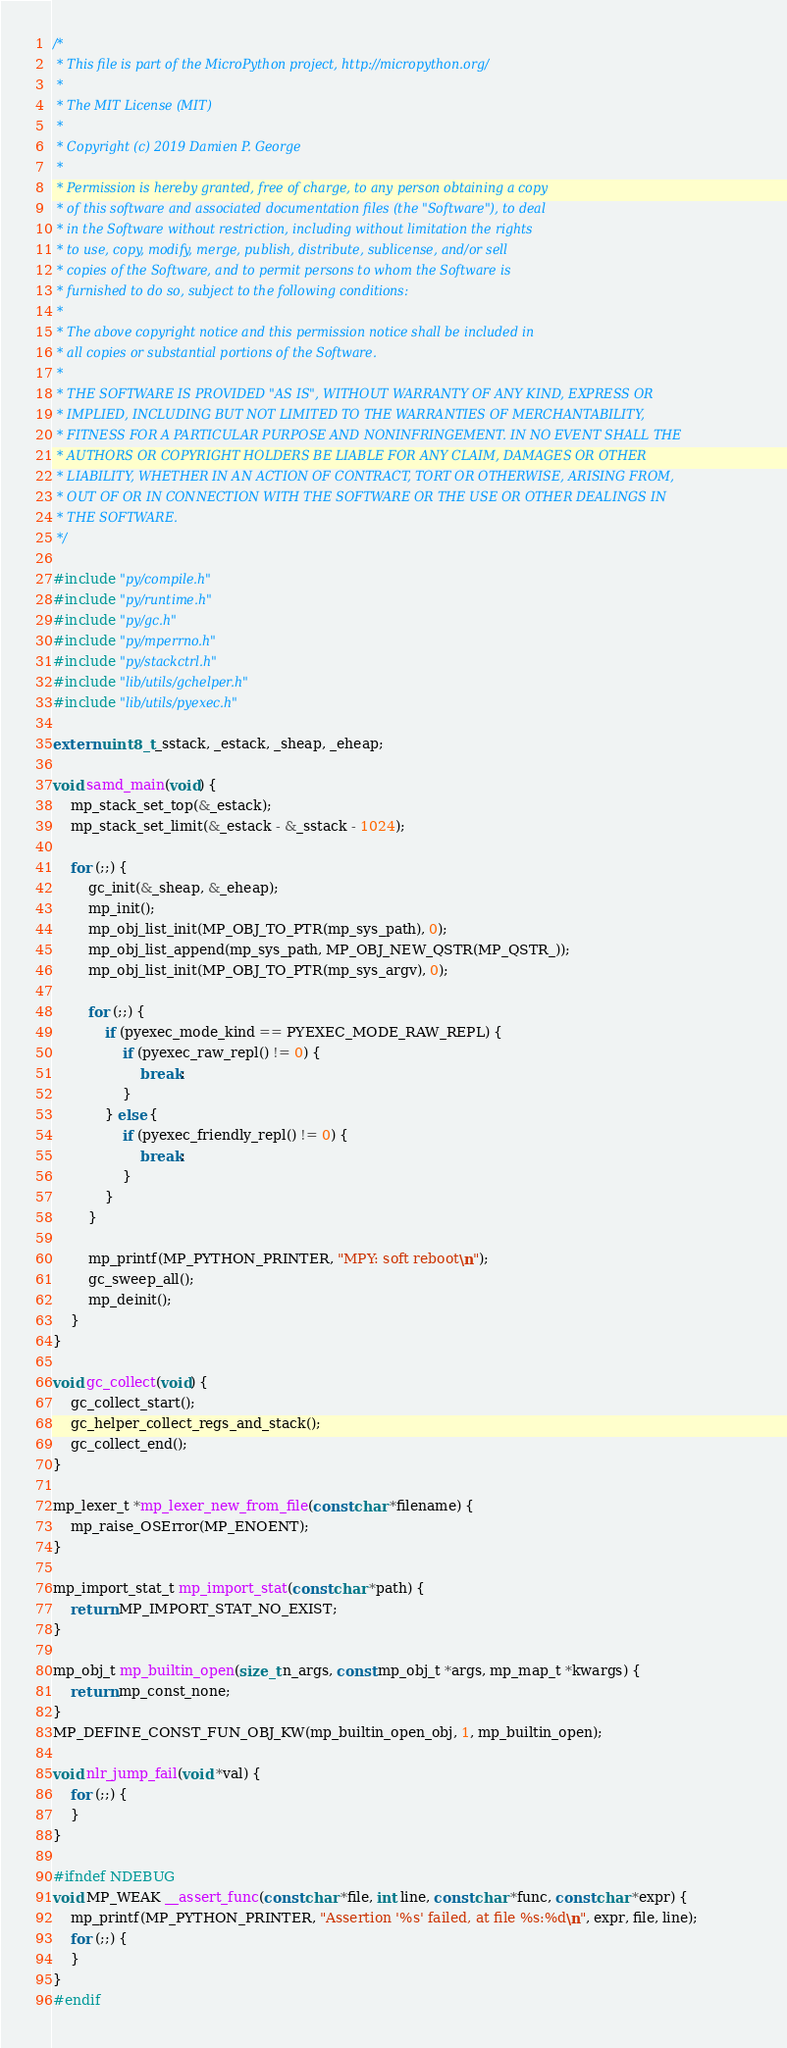<code> <loc_0><loc_0><loc_500><loc_500><_C_>/*
 * This file is part of the MicroPython project, http://micropython.org/
 *
 * The MIT License (MIT)
 *
 * Copyright (c) 2019 Damien P. George
 *
 * Permission is hereby granted, free of charge, to any person obtaining a copy
 * of this software and associated documentation files (the "Software"), to deal
 * in the Software without restriction, including without limitation the rights
 * to use, copy, modify, merge, publish, distribute, sublicense, and/or sell
 * copies of the Software, and to permit persons to whom the Software is
 * furnished to do so, subject to the following conditions:
 *
 * The above copyright notice and this permission notice shall be included in
 * all copies or substantial portions of the Software.
 *
 * THE SOFTWARE IS PROVIDED "AS IS", WITHOUT WARRANTY OF ANY KIND, EXPRESS OR
 * IMPLIED, INCLUDING BUT NOT LIMITED TO THE WARRANTIES OF MERCHANTABILITY,
 * FITNESS FOR A PARTICULAR PURPOSE AND NONINFRINGEMENT. IN NO EVENT SHALL THE
 * AUTHORS OR COPYRIGHT HOLDERS BE LIABLE FOR ANY CLAIM, DAMAGES OR OTHER
 * LIABILITY, WHETHER IN AN ACTION OF CONTRACT, TORT OR OTHERWISE, ARISING FROM,
 * OUT OF OR IN CONNECTION WITH THE SOFTWARE OR THE USE OR OTHER DEALINGS IN
 * THE SOFTWARE.
 */

#include "py/compile.h"
#include "py/runtime.h"
#include "py/gc.h"
#include "py/mperrno.h"
#include "py/stackctrl.h"
#include "lib/utils/gchelper.h"
#include "lib/utils/pyexec.h"

extern uint8_t _sstack, _estack, _sheap, _eheap;

void samd_main(void) {
    mp_stack_set_top(&_estack);
    mp_stack_set_limit(&_estack - &_sstack - 1024);

    for (;;) {
        gc_init(&_sheap, &_eheap);
        mp_init();
        mp_obj_list_init(MP_OBJ_TO_PTR(mp_sys_path), 0);
        mp_obj_list_append(mp_sys_path, MP_OBJ_NEW_QSTR(MP_QSTR_));
        mp_obj_list_init(MP_OBJ_TO_PTR(mp_sys_argv), 0);

        for (;;) {
            if (pyexec_mode_kind == PYEXEC_MODE_RAW_REPL) {
                if (pyexec_raw_repl() != 0) {
                    break;
                }
            } else {
                if (pyexec_friendly_repl() != 0) {
                    break;
                }
            }
        }

        mp_printf(MP_PYTHON_PRINTER, "MPY: soft reboot\n");
        gc_sweep_all();
        mp_deinit();
    }
}

void gc_collect(void) {
    gc_collect_start();
    gc_helper_collect_regs_and_stack();
    gc_collect_end();
}

mp_lexer_t *mp_lexer_new_from_file(const char *filename) {
    mp_raise_OSError(MP_ENOENT);
}

mp_import_stat_t mp_import_stat(const char *path) {
    return MP_IMPORT_STAT_NO_EXIST;
}

mp_obj_t mp_builtin_open(size_t n_args, const mp_obj_t *args, mp_map_t *kwargs) {
    return mp_const_none;
}
MP_DEFINE_CONST_FUN_OBJ_KW(mp_builtin_open_obj, 1, mp_builtin_open);

void nlr_jump_fail(void *val) {
    for (;;) {
    }
}

#ifndef NDEBUG
void MP_WEAK __assert_func(const char *file, int line, const char *func, const char *expr) {
    mp_printf(MP_PYTHON_PRINTER, "Assertion '%s' failed, at file %s:%d\n", expr, file, line);
    for (;;) {
    }
}
#endif
</code> 